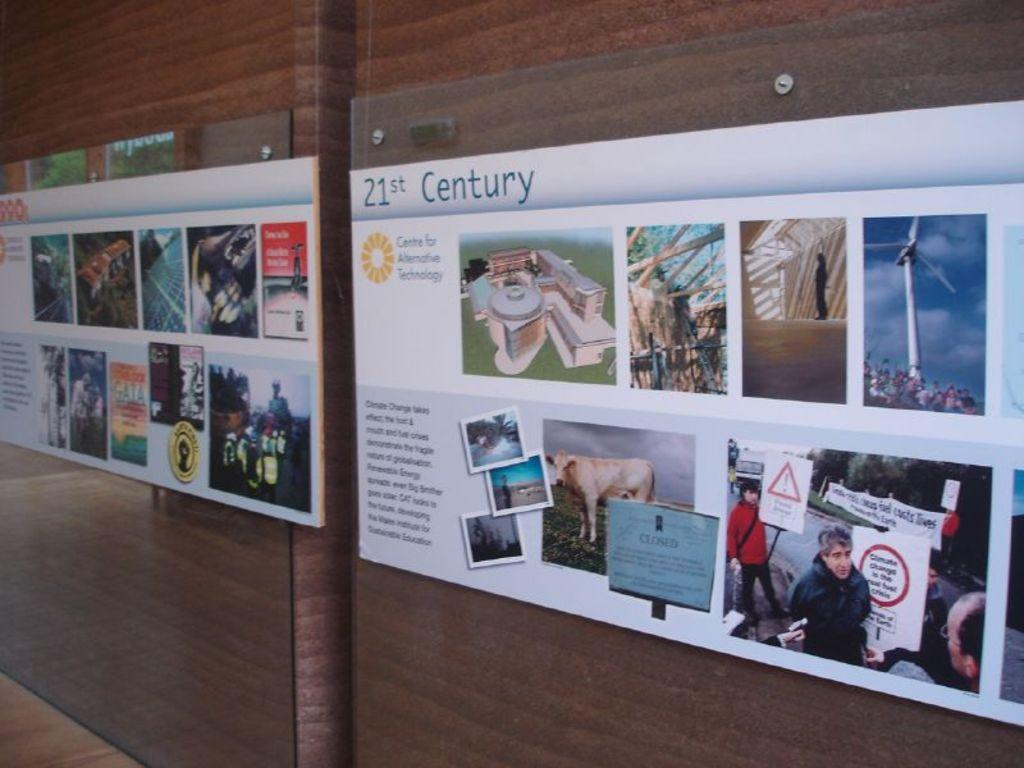<image>
Create a compact narrative representing the image presented. A display showing various 21st Century activities and devices. 